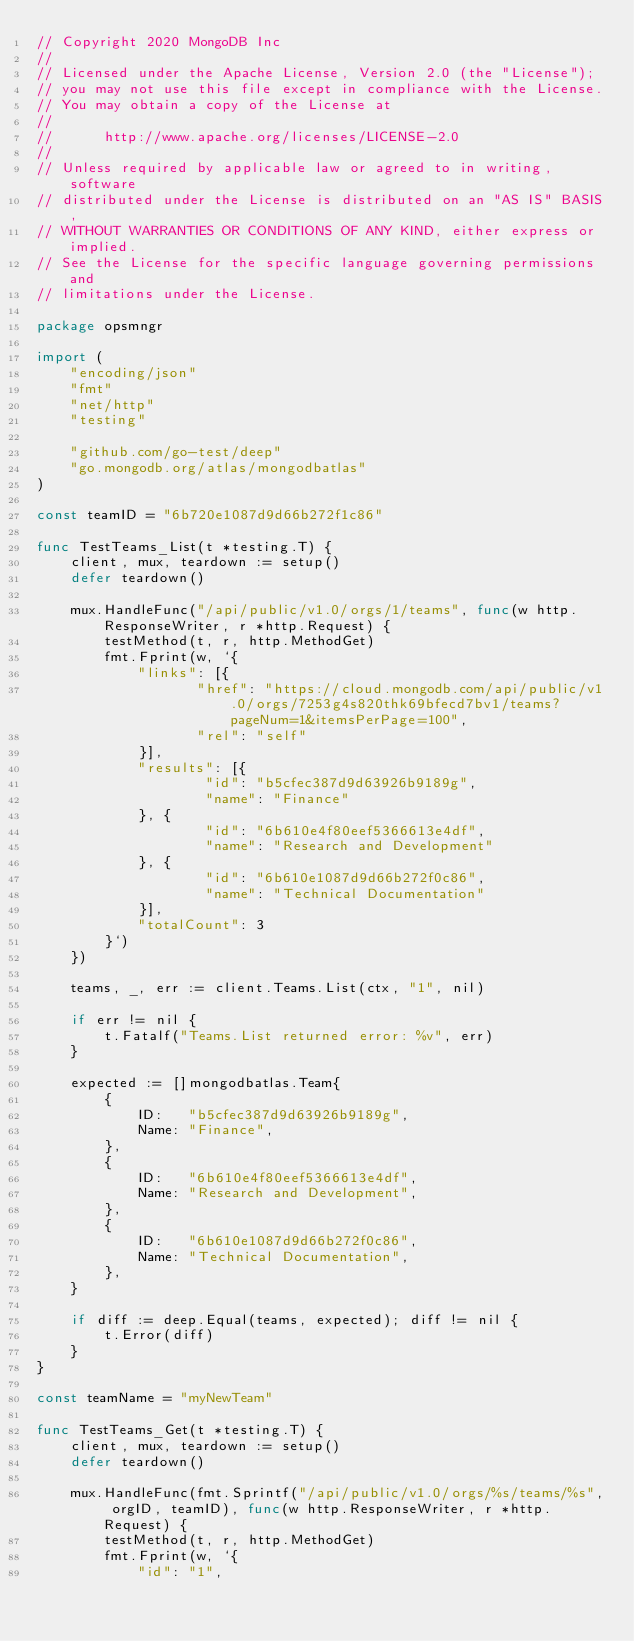Convert code to text. <code><loc_0><loc_0><loc_500><loc_500><_Go_>// Copyright 2020 MongoDB Inc
//
// Licensed under the Apache License, Version 2.0 (the "License");
// you may not use this file except in compliance with the License.
// You may obtain a copy of the License at
//
//      http://www.apache.org/licenses/LICENSE-2.0
//
// Unless required by applicable law or agreed to in writing, software
// distributed under the License is distributed on an "AS IS" BASIS,
// WITHOUT WARRANTIES OR CONDITIONS OF ANY KIND, either express or implied.
// See the License for the specific language governing permissions and
// limitations under the License.

package opsmngr

import (
	"encoding/json"
	"fmt"
	"net/http"
	"testing"

	"github.com/go-test/deep"
	"go.mongodb.org/atlas/mongodbatlas"
)

const teamID = "6b720e1087d9d66b272f1c86"

func TestTeams_List(t *testing.T) {
	client, mux, teardown := setup()
	defer teardown()

	mux.HandleFunc("/api/public/v1.0/orgs/1/teams", func(w http.ResponseWriter, r *http.Request) {
		testMethod(t, r, http.MethodGet)
		fmt.Fprint(w, `{
			"links": [{
				   "href": "https://cloud.mongodb.com/api/public/v1.0/orgs/7253g4s820thk69bfecd7bv1/teams?pageNum=1&itemsPerPage=100",
				   "rel": "self"
			}],
			"results": [{
					"id": "b5cfec387d9d63926b9189g",
					"name": "Finance"
			}, {
					"id": "6b610e4f80eef5366613e4df",
					"name": "Research and Development"
			}, {
					"id": "6b610e1087d9d66b272f0c86",
					"name": "Technical Documentation"
			}],
			"totalCount": 3
		}`)
	})

	teams, _, err := client.Teams.List(ctx, "1", nil)

	if err != nil {
		t.Fatalf("Teams.List returned error: %v", err)
	}

	expected := []mongodbatlas.Team{
		{
			ID:   "b5cfec387d9d63926b9189g",
			Name: "Finance",
		},
		{
			ID:   "6b610e4f80eef5366613e4df",
			Name: "Research and Development",
		},
		{
			ID:   "6b610e1087d9d66b272f0c86",
			Name: "Technical Documentation",
		},
	}

	if diff := deep.Equal(teams, expected); diff != nil {
		t.Error(diff)
	}
}

const teamName = "myNewTeam"

func TestTeams_Get(t *testing.T) {
	client, mux, teardown := setup()
	defer teardown()

	mux.HandleFunc(fmt.Sprintf("/api/public/v1.0/orgs/%s/teams/%s", orgID, teamID), func(w http.ResponseWriter, r *http.Request) {
		testMethod(t, r, http.MethodGet)
		fmt.Fprint(w, `{
			"id": "1",</code> 